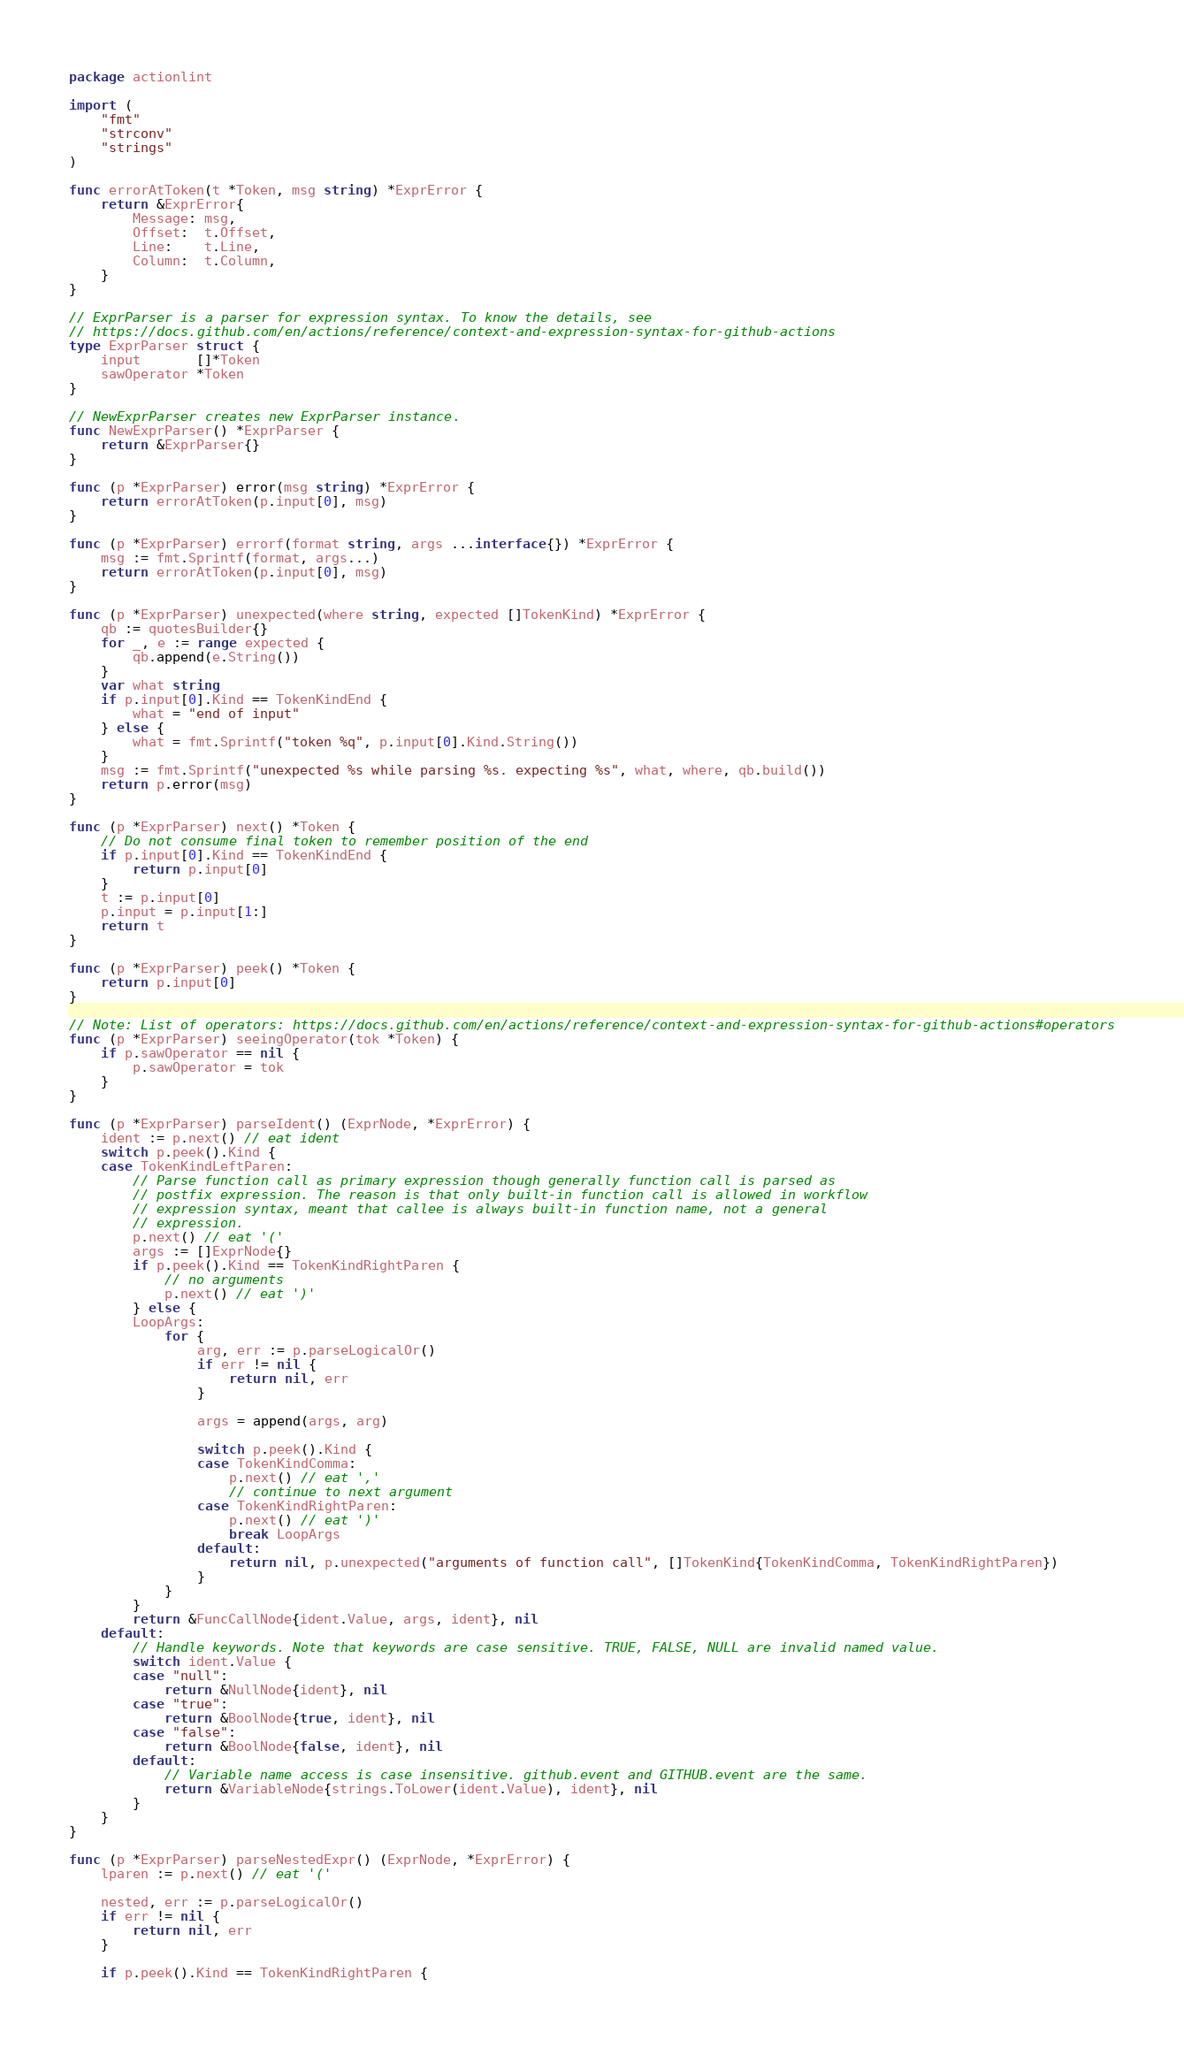<code> <loc_0><loc_0><loc_500><loc_500><_Go_>package actionlint

import (
	"fmt"
	"strconv"
	"strings"
)

func errorAtToken(t *Token, msg string) *ExprError {
	return &ExprError{
		Message: msg,
		Offset:  t.Offset,
		Line:    t.Line,
		Column:  t.Column,
	}
}

// ExprParser is a parser for expression syntax. To know the details, see
// https://docs.github.com/en/actions/reference/context-and-expression-syntax-for-github-actions
type ExprParser struct {
	input       []*Token
	sawOperator *Token
}

// NewExprParser creates new ExprParser instance.
func NewExprParser() *ExprParser {
	return &ExprParser{}
}

func (p *ExprParser) error(msg string) *ExprError {
	return errorAtToken(p.input[0], msg)
}

func (p *ExprParser) errorf(format string, args ...interface{}) *ExprError {
	msg := fmt.Sprintf(format, args...)
	return errorAtToken(p.input[0], msg)
}

func (p *ExprParser) unexpected(where string, expected []TokenKind) *ExprError {
	qb := quotesBuilder{}
	for _, e := range expected {
		qb.append(e.String())
	}
	var what string
	if p.input[0].Kind == TokenKindEnd {
		what = "end of input"
	} else {
		what = fmt.Sprintf("token %q", p.input[0].Kind.String())
	}
	msg := fmt.Sprintf("unexpected %s while parsing %s. expecting %s", what, where, qb.build())
	return p.error(msg)
}

func (p *ExprParser) next() *Token {
	// Do not consume final token to remember position of the end
	if p.input[0].Kind == TokenKindEnd {
		return p.input[0]
	}
	t := p.input[0]
	p.input = p.input[1:]
	return t
}

func (p *ExprParser) peek() *Token {
	return p.input[0]
}

// Note: List of operators: https://docs.github.com/en/actions/reference/context-and-expression-syntax-for-github-actions#operators
func (p *ExprParser) seeingOperator(tok *Token) {
	if p.sawOperator == nil {
		p.sawOperator = tok
	}
}

func (p *ExprParser) parseIdent() (ExprNode, *ExprError) {
	ident := p.next() // eat ident
	switch p.peek().Kind {
	case TokenKindLeftParen:
		// Parse function call as primary expression though generally function call is parsed as
		// postfix expression. The reason is that only built-in function call is allowed in workflow
		// expression syntax, meant that callee is always built-in function name, not a general
		// expression.
		p.next() // eat '('
		args := []ExprNode{}
		if p.peek().Kind == TokenKindRightParen {
			// no arguments
			p.next() // eat ')'
		} else {
		LoopArgs:
			for {
				arg, err := p.parseLogicalOr()
				if err != nil {
					return nil, err
				}

				args = append(args, arg)

				switch p.peek().Kind {
				case TokenKindComma:
					p.next() // eat ','
					// continue to next argument
				case TokenKindRightParen:
					p.next() // eat ')'
					break LoopArgs
				default:
					return nil, p.unexpected("arguments of function call", []TokenKind{TokenKindComma, TokenKindRightParen})
				}
			}
		}
		return &FuncCallNode{ident.Value, args, ident}, nil
	default:
		// Handle keywords. Note that keywords are case sensitive. TRUE, FALSE, NULL are invalid named value.
		switch ident.Value {
		case "null":
			return &NullNode{ident}, nil
		case "true":
			return &BoolNode{true, ident}, nil
		case "false":
			return &BoolNode{false, ident}, nil
		default:
			// Variable name access is case insensitive. github.event and GITHUB.event are the same.
			return &VariableNode{strings.ToLower(ident.Value), ident}, nil
		}
	}
}

func (p *ExprParser) parseNestedExpr() (ExprNode, *ExprError) {
	lparen := p.next() // eat '('

	nested, err := p.parseLogicalOr()
	if err != nil {
		return nil, err
	}

	if p.peek().Kind == TokenKindRightParen {</code> 